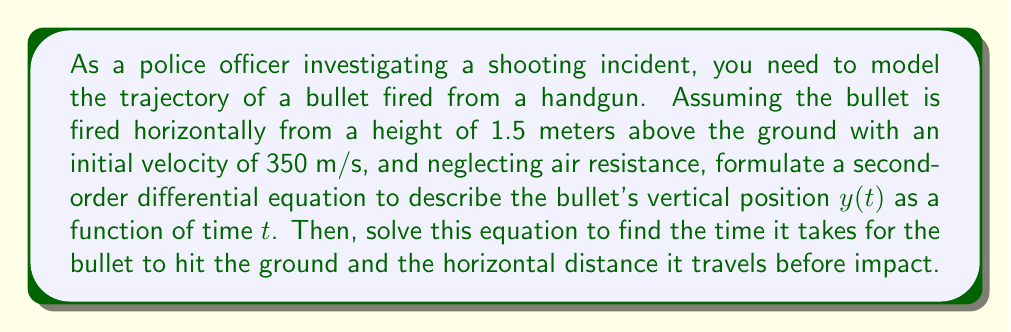What is the answer to this math problem? Let's approach this step-by-step:

1) The motion of the bullet can be described by a second-order differential equation based on Newton's second law of motion:

   $$\frac{d^2y}{dt^2} = -g$$

   where $g$ is the acceleration due to gravity (approximately 9.8 m/s²).

2) We need to solve this equation with the following initial conditions:
   - Initial height: $y(0) = 1.5$ m
   - Initial vertical velocity: $\frac{dy}{dt}(0) = 0$ m/s (since the bullet is fired horizontally)

3) Integrating the differential equation once:

   $$\frac{dy}{dt} = -gt + C_1$$

4) Using the initial condition for velocity:

   $$0 = -g(0) + C_1$$
   $$C_1 = 0$$

5) Integrating again:

   $$y = -\frac{1}{2}gt^2 + C_2$$

6) Using the initial condition for height:

   $$1.5 = -\frac{1}{2}g(0)^2 + C_2$$
   $$C_2 = 1.5$$

7) Therefore, the equation for the bullet's height as a function of time is:

   $$y = -\frac{1}{2}gt^2 + 1.5$$

8) To find the time when the bullet hits the ground, set $y = 0$:

   $$0 = -\frac{1}{2}gt^2 + 1.5$$
   $$\frac{1}{2}gt^2 = 1.5$$
   $$t^2 = \frac{3}{g}$$
   $$t = \sqrt{\frac{3}{g}} \approx 0.5528 \text{ seconds}$$

9) The horizontal distance traveled is the product of the initial velocity and the time:

   $$d = v_0t = 350 \cdot 0.5528 \approx 193.48 \text{ meters}$$
Answer: The time it takes for the bullet to hit the ground is approximately 0.5528 seconds, and the horizontal distance it travels before impact is approximately 193.48 meters. 